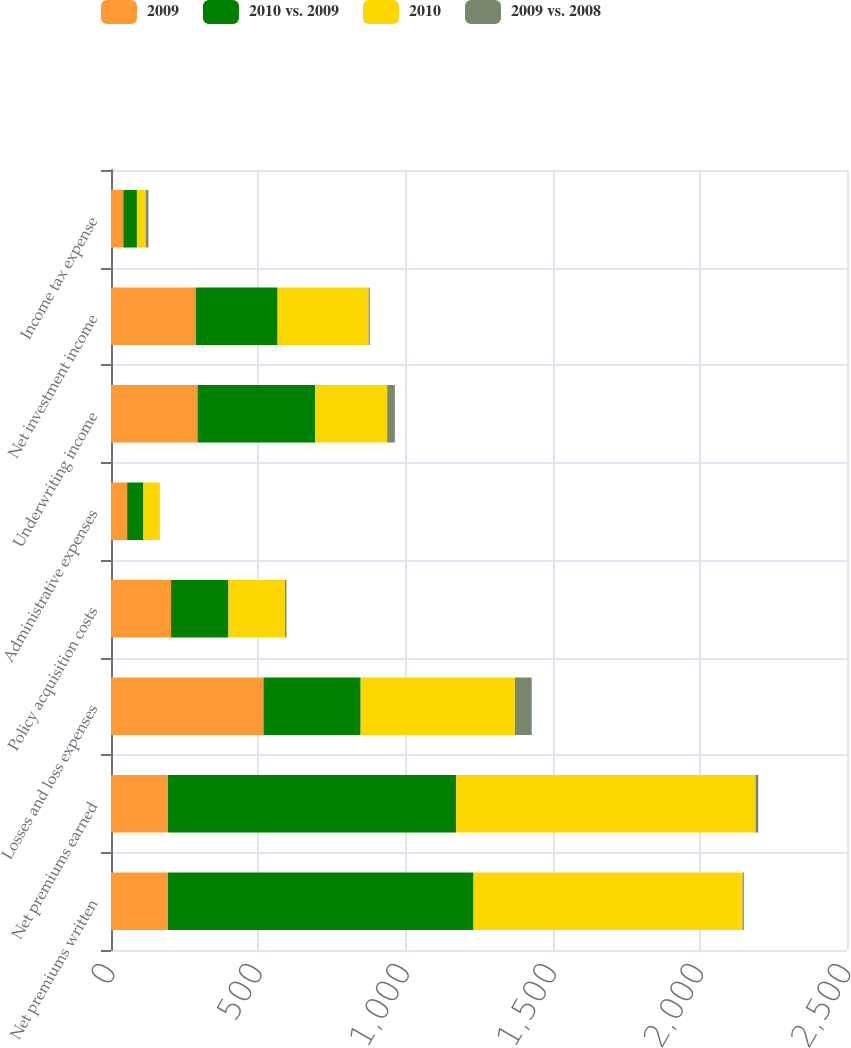Convert chart to OTSL. <chart><loc_0><loc_0><loc_500><loc_500><stacked_bar_chart><ecel><fcel>Net premiums written<fcel>Net premiums earned<fcel>Losses and loss expenses<fcel>Policy acquisition costs<fcel>Administrative expenses<fcel>Underwriting income<fcel>Net investment income<fcel>Income tax expense<nl><fcel>2009<fcel>193.5<fcel>193.5<fcel>518<fcel>204<fcel>55<fcel>294<fcel>288<fcel>42<nl><fcel>2010 vs. 2009<fcel>1038<fcel>979<fcel>330<fcel>195<fcel>55<fcel>399<fcel>278<fcel>46<nl><fcel>2010<fcel>914<fcel>1017<fcel>524<fcel>192<fcel>56<fcel>245<fcel>309<fcel>30<nl><fcel>2009 vs. 2008<fcel>4<fcel>9<fcel>57<fcel>5<fcel>0<fcel>26<fcel>4<fcel>9<nl></chart> 